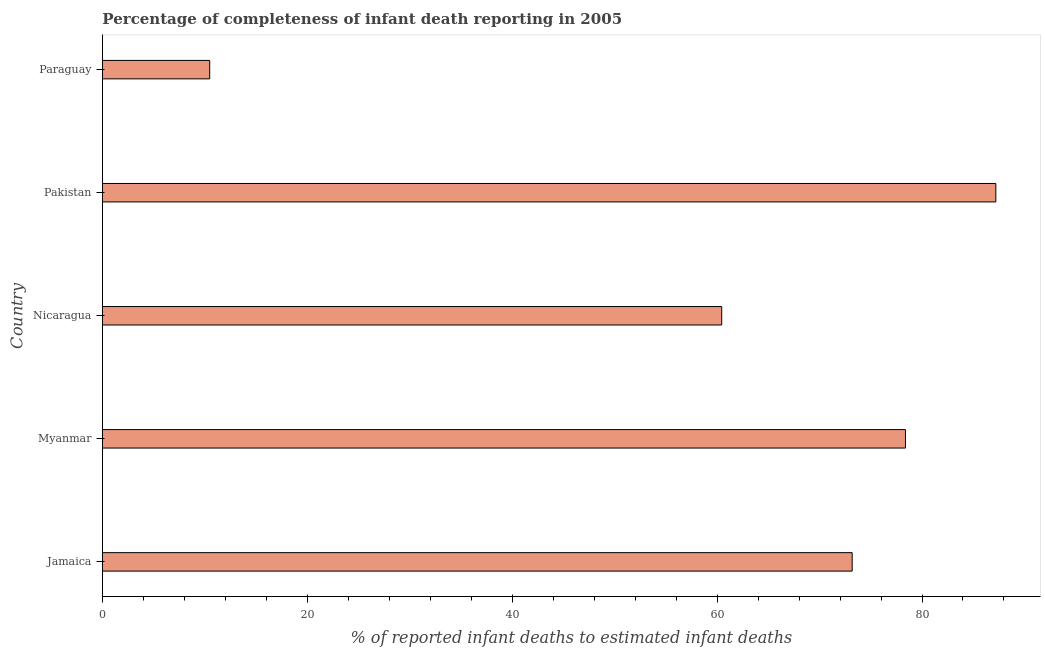Does the graph contain grids?
Your answer should be compact. No. What is the title of the graph?
Give a very brief answer. Percentage of completeness of infant death reporting in 2005. What is the label or title of the X-axis?
Your response must be concise. % of reported infant deaths to estimated infant deaths. What is the completeness of infant death reporting in Nicaragua?
Your answer should be very brief. 60.45. Across all countries, what is the maximum completeness of infant death reporting?
Make the answer very short. 87.21. Across all countries, what is the minimum completeness of infant death reporting?
Offer a very short reply. 10.47. In which country was the completeness of infant death reporting minimum?
Your answer should be compact. Paraguay. What is the sum of the completeness of infant death reporting?
Keep it short and to the point. 309.69. What is the difference between the completeness of infant death reporting in Nicaragua and Pakistan?
Make the answer very short. -26.76. What is the average completeness of infant death reporting per country?
Provide a short and direct response. 61.94. What is the median completeness of infant death reporting?
Your answer should be very brief. 73.18. What is the ratio of the completeness of infant death reporting in Jamaica to that in Pakistan?
Make the answer very short. 0.84. What is the difference between the highest and the second highest completeness of infant death reporting?
Offer a very short reply. 8.82. Is the sum of the completeness of infant death reporting in Jamaica and Nicaragua greater than the maximum completeness of infant death reporting across all countries?
Provide a short and direct response. Yes. What is the difference between the highest and the lowest completeness of infant death reporting?
Offer a terse response. 76.74. How many bars are there?
Offer a terse response. 5. Are all the bars in the graph horizontal?
Your answer should be very brief. Yes. What is the difference between two consecutive major ticks on the X-axis?
Ensure brevity in your answer.  20. Are the values on the major ticks of X-axis written in scientific E-notation?
Your response must be concise. No. What is the % of reported infant deaths to estimated infant deaths in Jamaica?
Keep it short and to the point. 73.18. What is the % of reported infant deaths to estimated infant deaths of Myanmar?
Your answer should be compact. 78.39. What is the % of reported infant deaths to estimated infant deaths in Nicaragua?
Your answer should be compact. 60.45. What is the % of reported infant deaths to estimated infant deaths in Pakistan?
Your answer should be compact. 87.21. What is the % of reported infant deaths to estimated infant deaths of Paraguay?
Your answer should be compact. 10.47. What is the difference between the % of reported infant deaths to estimated infant deaths in Jamaica and Myanmar?
Make the answer very short. -5.2. What is the difference between the % of reported infant deaths to estimated infant deaths in Jamaica and Nicaragua?
Offer a very short reply. 12.74. What is the difference between the % of reported infant deaths to estimated infant deaths in Jamaica and Pakistan?
Ensure brevity in your answer.  -14.02. What is the difference between the % of reported infant deaths to estimated infant deaths in Jamaica and Paraguay?
Provide a short and direct response. 62.72. What is the difference between the % of reported infant deaths to estimated infant deaths in Myanmar and Nicaragua?
Ensure brevity in your answer.  17.94. What is the difference between the % of reported infant deaths to estimated infant deaths in Myanmar and Pakistan?
Keep it short and to the point. -8.82. What is the difference between the % of reported infant deaths to estimated infant deaths in Myanmar and Paraguay?
Keep it short and to the point. 67.92. What is the difference between the % of reported infant deaths to estimated infant deaths in Nicaragua and Pakistan?
Give a very brief answer. -26.76. What is the difference between the % of reported infant deaths to estimated infant deaths in Nicaragua and Paraguay?
Make the answer very short. 49.98. What is the difference between the % of reported infant deaths to estimated infant deaths in Pakistan and Paraguay?
Give a very brief answer. 76.74. What is the ratio of the % of reported infant deaths to estimated infant deaths in Jamaica to that in Myanmar?
Offer a very short reply. 0.93. What is the ratio of the % of reported infant deaths to estimated infant deaths in Jamaica to that in Nicaragua?
Keep it short and to the point. 1.21. What is the ratio of the % of reported infant deaths to estimated infant deaths in Jamaica to that in Pakistan?
Offer a terse response. 0.84. What is the ratio of the % of reported infant deaths to estimated infant deaths in Jamaica to that in Paraguay?
Offer a terse response. 6.99. What is the ratio of the % of reported infant deaths to estimated infant deaths in Myanmar to that in Nicaragua?
Your answer should be compact. 1.3. What is the ratio of the % of reported infant deaths to estimated infant deaths in Myanmar to that in Pakistan?
Offer a terse response. 0.9. What is the ratio of the % of reported infant deaths to estimated infant deaths in Myanmar to that in Paraguay?
Your answer should be very brief. 7.49. What is the ratio of the % of reported infant deaths to estimated infant deaths in Nicaragua to that in Pakistan?
Your answer should be compact. 0.69. What is the ratio of the % of reported infant deaths to estimated infant deaths in Nicaragua to that in Paraguay?
Offer a very short reply. 5.78. What is the ratio of the % of reported infant deaths to estimated infant deaths in Pakistan to that in Paraguay?
Provide a succinct answer. 8.33. 